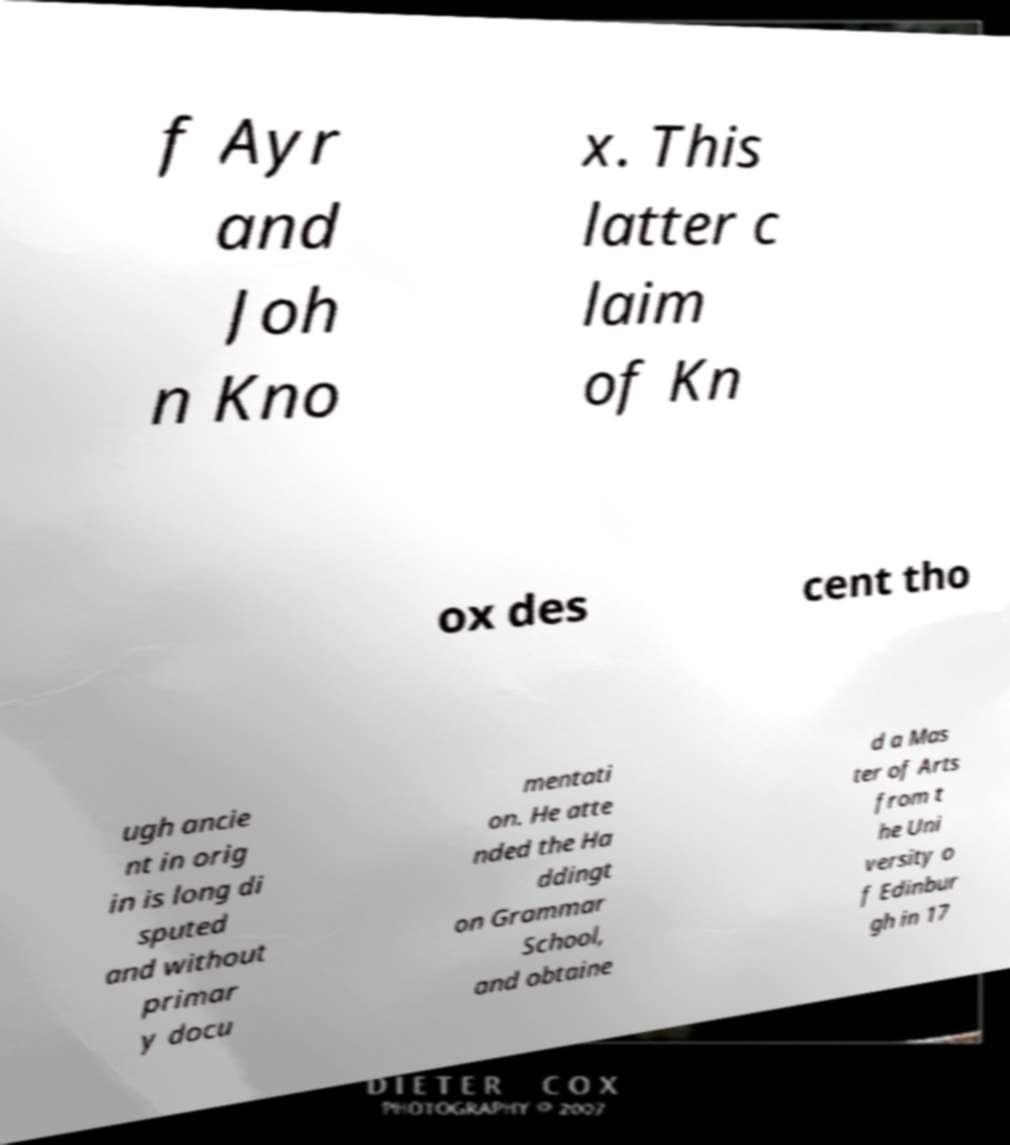Can you read and provide the text displayed in the image?This photo seems to have some interesting text. Can you extract and type it out for me? f Ayr and Joh n Kno x. This latter c laim of Kn ox des cent tho ugh ancie nt in orig in is long di sputed and without primar y docu mentati on. He atte nded the Ha ddingt on Grammar School, and obtaine d a Mas ter of Arts from t he Uni versity o f Edinbur gh in 17 